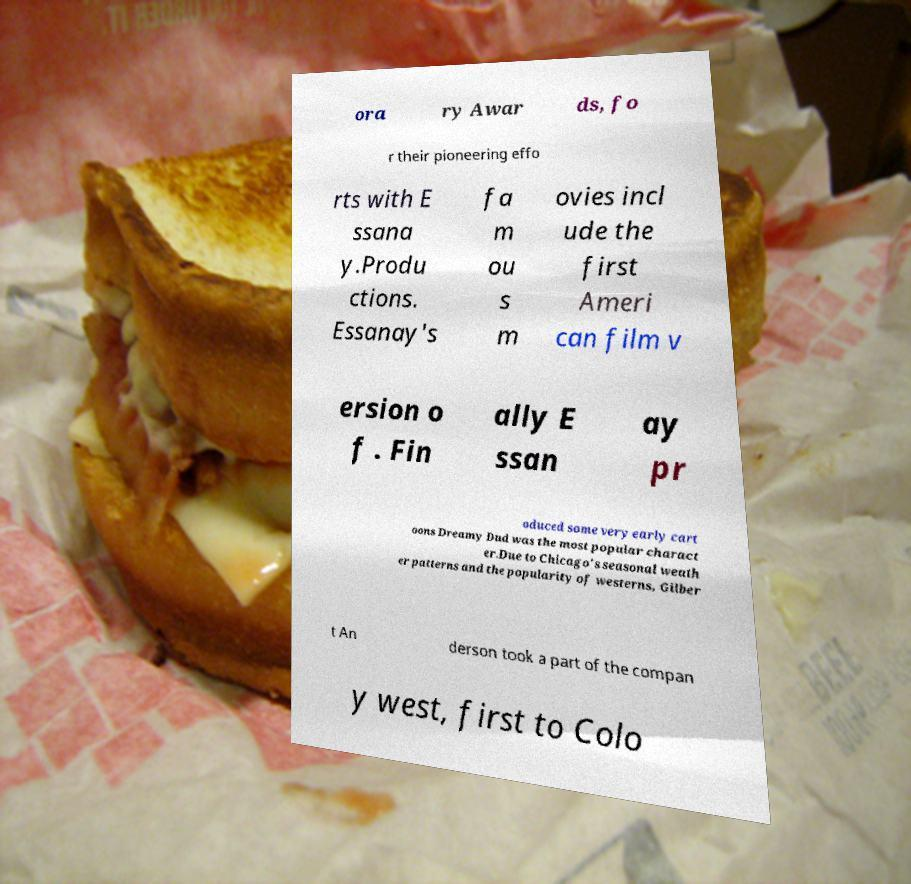Please read and relay the text visible in this image. What does it say? ora ry Awar ds, fo r their pioneering effo rts with E ssana y.Produ ctions. Essanay's fa m ou s m ovies incl ude the first Ameri can film v ersion o f . Fin ally E ssan ay pr oduced some very early cart oons Dreamy Dud was the most popular charact er.Due to Chicago's seasonal weath er patterns and the popularity of westerns, Gilber t An derson took a part of the compan y west, first to Colo 